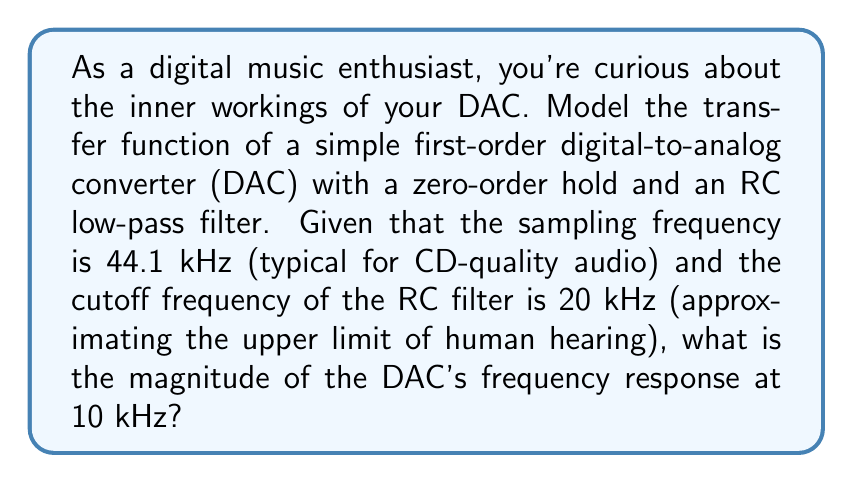Show me your answer to this math problem. To model the transfer function of the DAC, we need to consider two main components:

1. The zero-order hold (ZOH)
2. The RC low-pass filter

1. Zero-order hold transfer function:
The ZOH transfer function is given by:

$$ H_{ZOH}(s) = \frac{1 - e^{-sT_s}}{s} $$

Where $T_s$ is the sampling period. Given the sampling frequency $f_s = 44.1$ kHz,

$$ T_s = \frac{1}{f_s} = \frac{1}{44100} \approx 22.68 \mu s $$

2. RC low-pass filter transfer function:
The transfer function of a first-order low-pass filter is:

$$ H_{RC}(s) = \frac{1}{1 + s/\omega_c} $$

Where $\omega_c = 2\pi f_c$, and $f_c$ is the cutoff frequency (20 kHz).

The overall transfer function of the DAC is the product of these two:

$$ H_{DAC}(s) = H_{ZOH}(s) \cdot H_{RC}(s) = \frac{1 - e^{-sT_s}}{s} \cdot \frac{1}{1 + s/\omega_c} $$

To find the magnitude of the frequency response at 10 kHz, we need to evaluate:

$$ |H_{DAC}(j\omega)| \text{ at } \omega = 2\pi \cdot 10000 $$

Substituting the values:

$$ |H_{DAC}(j\omega)| = \left|\frac{1 - e^{-j\omega T_s}}{j\omega} \cdot \frac{1}{1 + j\omega/\omega_c}\right| $$

$$ = \left|\frac{1 - e^{-j2\pi \cdot 10000 \cdot 22.68 \times 10^{-6}}}{j2\pi \cdot 10000} \cdot \frac{1}{1 + j2\pi \cdot 10000/(2\pi \cdot 20000)}\right| $$

$$ = \left|\frac{1 - e^{-j1.4248}}{j2\pi \cdot 10000} \cdot \frac{1}{1 + j0.5}\right| $$

Evaluating this expression numerically (using a calculator or computer software) gives us the magnitude of the frequency response at 10 kHz.
Answer: The magnitude of the DAC's frequency response at 10 kHz is approximately 0.8913 (-1.00 dB). 